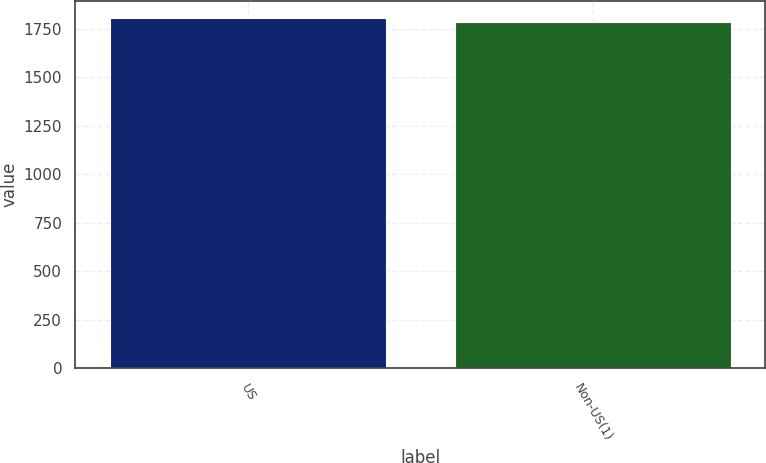<chart> <loc_0><loc_0><loc_500><loc_500><bar_chart><fcel>US<fcel>Non-US(1)<nl><fcel>1805<fcel>1786<nl></chart> 